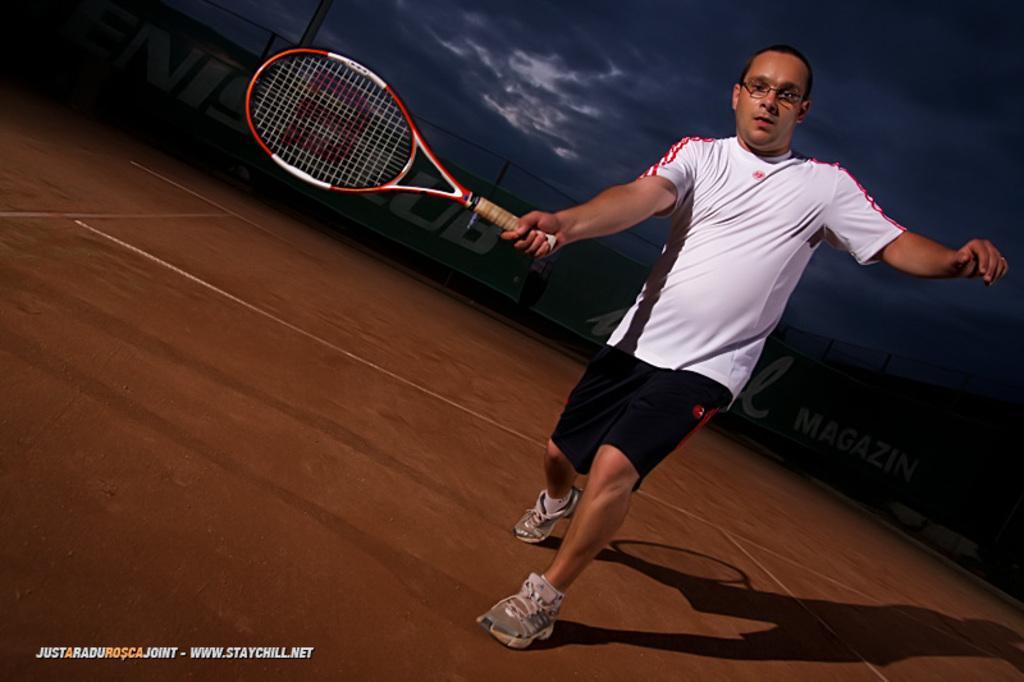Describe this image in one or two sentences. In this image there is a person standing and holding a tennis racket , and there are boards, sky, and a watermark on the image. 